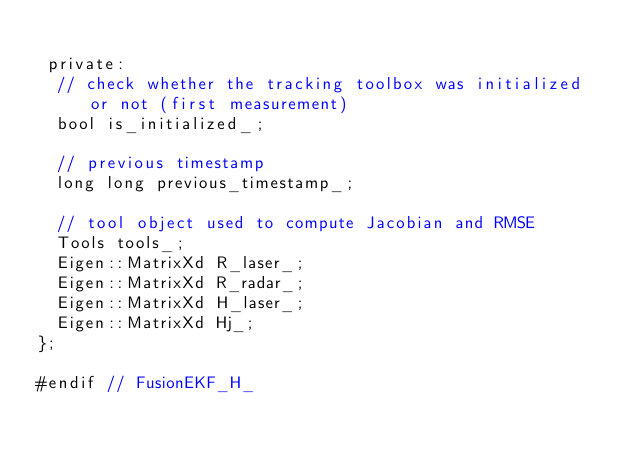Convert code to text. <code><loc_0><loc_0><loc_500><loc_500><_C_>
 private:
  // check whether the tracking toolbox was initialized or not (first measurement)
  bool is_initialized_;

  // previous timestamp
  long long previous_timestamp_;

  // tool object used to compute Jacobian and RMSE
  Tools tools_;
  Eigen::MatrixXd R_laser_;
  Eigen::MatrixXd R_radar_;
  Eigen::MatrixXd H_laser_;
  Eigen::MatrixXd Hj_;
};

#endif // FusionEKF_H_
</code> 